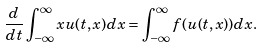<formula> <loc_0><loc_0><loc_500><loc_500>\frac { d } { d t } \int _ { - \infty } ^ { \infty } x u ( t , x ) d x = \int _ { - \infty } ^ { \infty } f ( u ( t , x ) ) d x .</formula> 